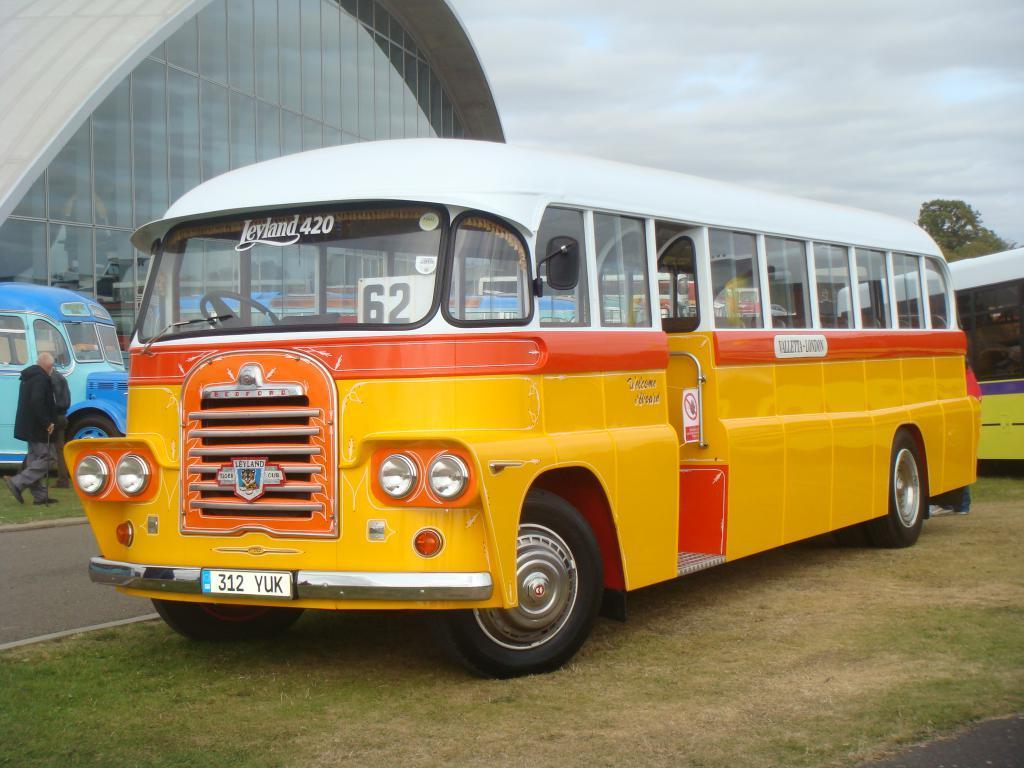In one or two sentences, can you explain what this image depicts? This is an outside view. In this image I can see three buses on the ground. On the left side there is a road and there are two persons. One person is walking. In the background there is a building. At the top of the image I can see the sky. On the right side there are few trees. 